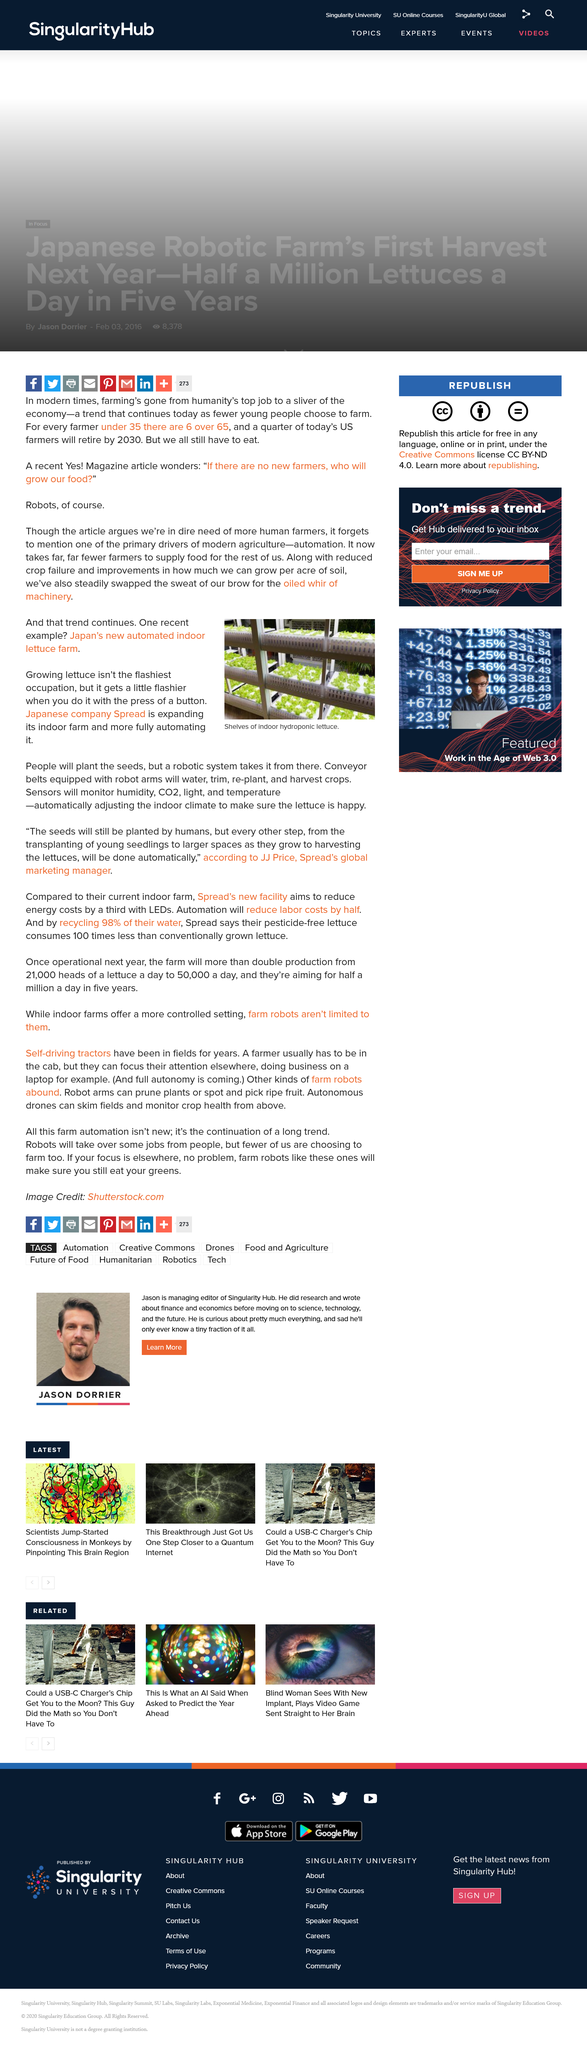Identify some key points in this picture. It is reported that Spread, a Japanese company, has an indoor lettuce farm. The photograph shows a vegetable that is lettuce, and lettuce is featured in the photograph. Japan is the country that boasts an automated indoor lettuce farm. 